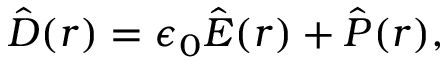<formula> <loc_0><loc_0><loc_500><loc_500>\hat { \boldsymbol D } ( \boldsymbol r ) = \epsilon _ { 0 } \hat { \boldsymbol E } ( \boldsymbol r ) + \hat { \boldsymbol P } ( \boldsymbol r ) ,</formula> 